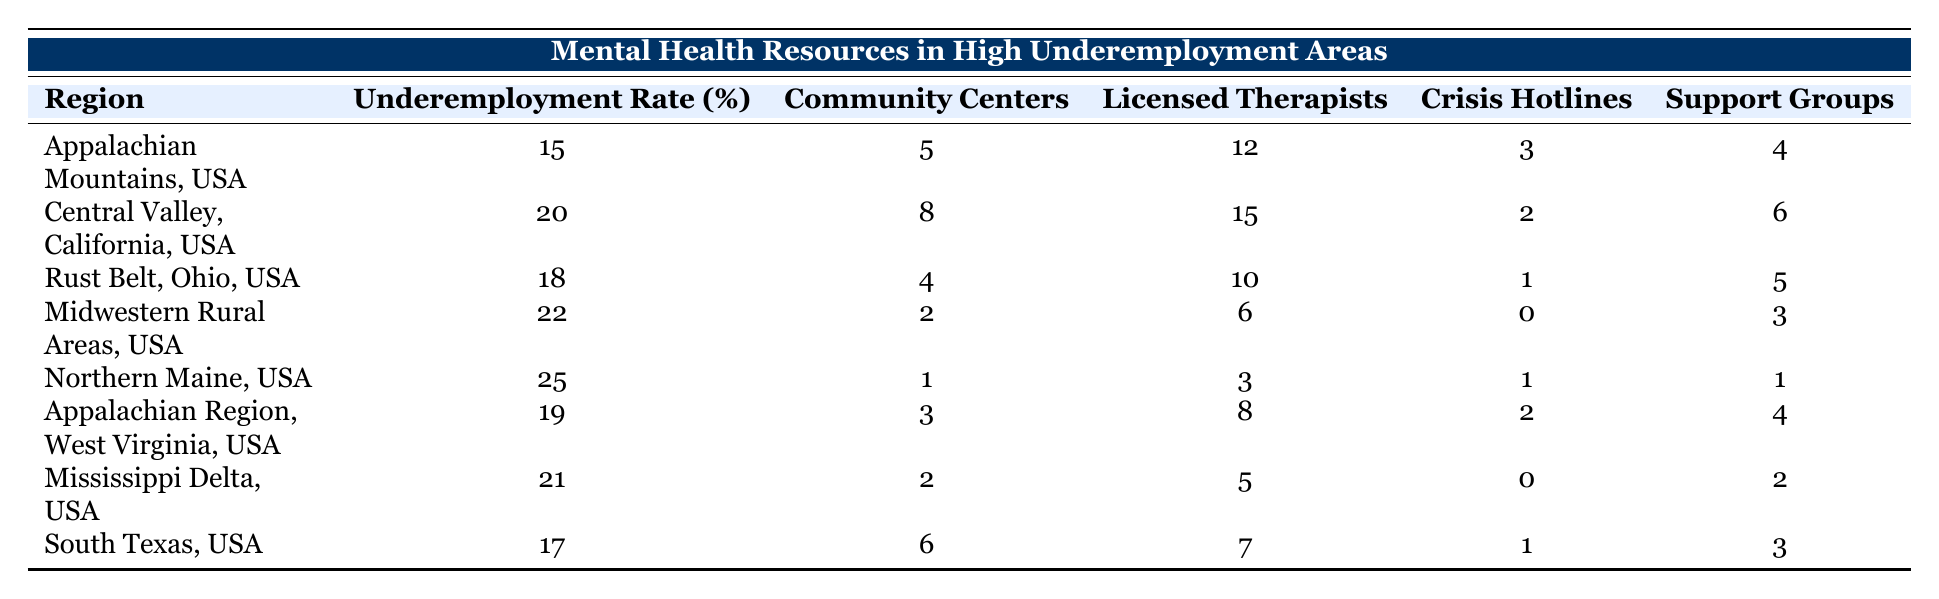What is the underemployment rate in Northern Maine? The underemployment rate for Northern Maine is listed directly in the table under the specified region. It shows 25%.
Answer: 25 Which region has the highest number of licensed therapists? The table shows the number of licensed therapists for each region. Central Valley, California, has the highest number with 15 licensed therapists.
Answer: 15 How many community centers are there in the Midwestern Rural Areas? The table directly lists the number of community centers in the Midwestern Rural Areas as 2.
Answer: 2 What is the sum of crisis hotlines across all regions? To find this sum, add the number of crisis hotlines from each region: 3 + 2 + 1 + 0 + 1 + 2 + 0 + 1 = 10.
Answer: 10 Is there a region with no licensed therapists? By reviewing the table, we check if any region lists 0 licensed therapists. The Midwestern Rural Areas show 6 but Northern Maine shows 3. Hence, all regions have at least some licensed therapists.
Answer: No Which region has more support groups, the Appalachian Mountains or South Texas? The table shows that Appalachian Mountains has 4 support groups, while South Texas has 3. Therefore, the Appalachian Mountains has more.
Answer: Appalachian Mountains What is the average underemployment rate for all regions? To find the average, first sum up all underemployment rates: 15 + 20 + 18 + 22 + 25 + 19 + 21 + 17 = 157. There are 8 regions, so the average is 157/8 = 19.625, which rounds to about 19.6.
Answer: 19.6 In which regions is the number of community centers greater than 5? By examining the table, the regions with more than 5 community centers are Appalachian Mountains (5), Central Valley (8), and South Texas (6). This results in only two regions meeting the criteria.
Answer: 2 regions What is the difference in the number of support groups between the region with the most and the least? Considering the number of support groups, the region with the most is Central Valley with 6, and the least is Northern Maine with 1. The difference is calculated as 6 - 1 = 5.
Answer: 5 